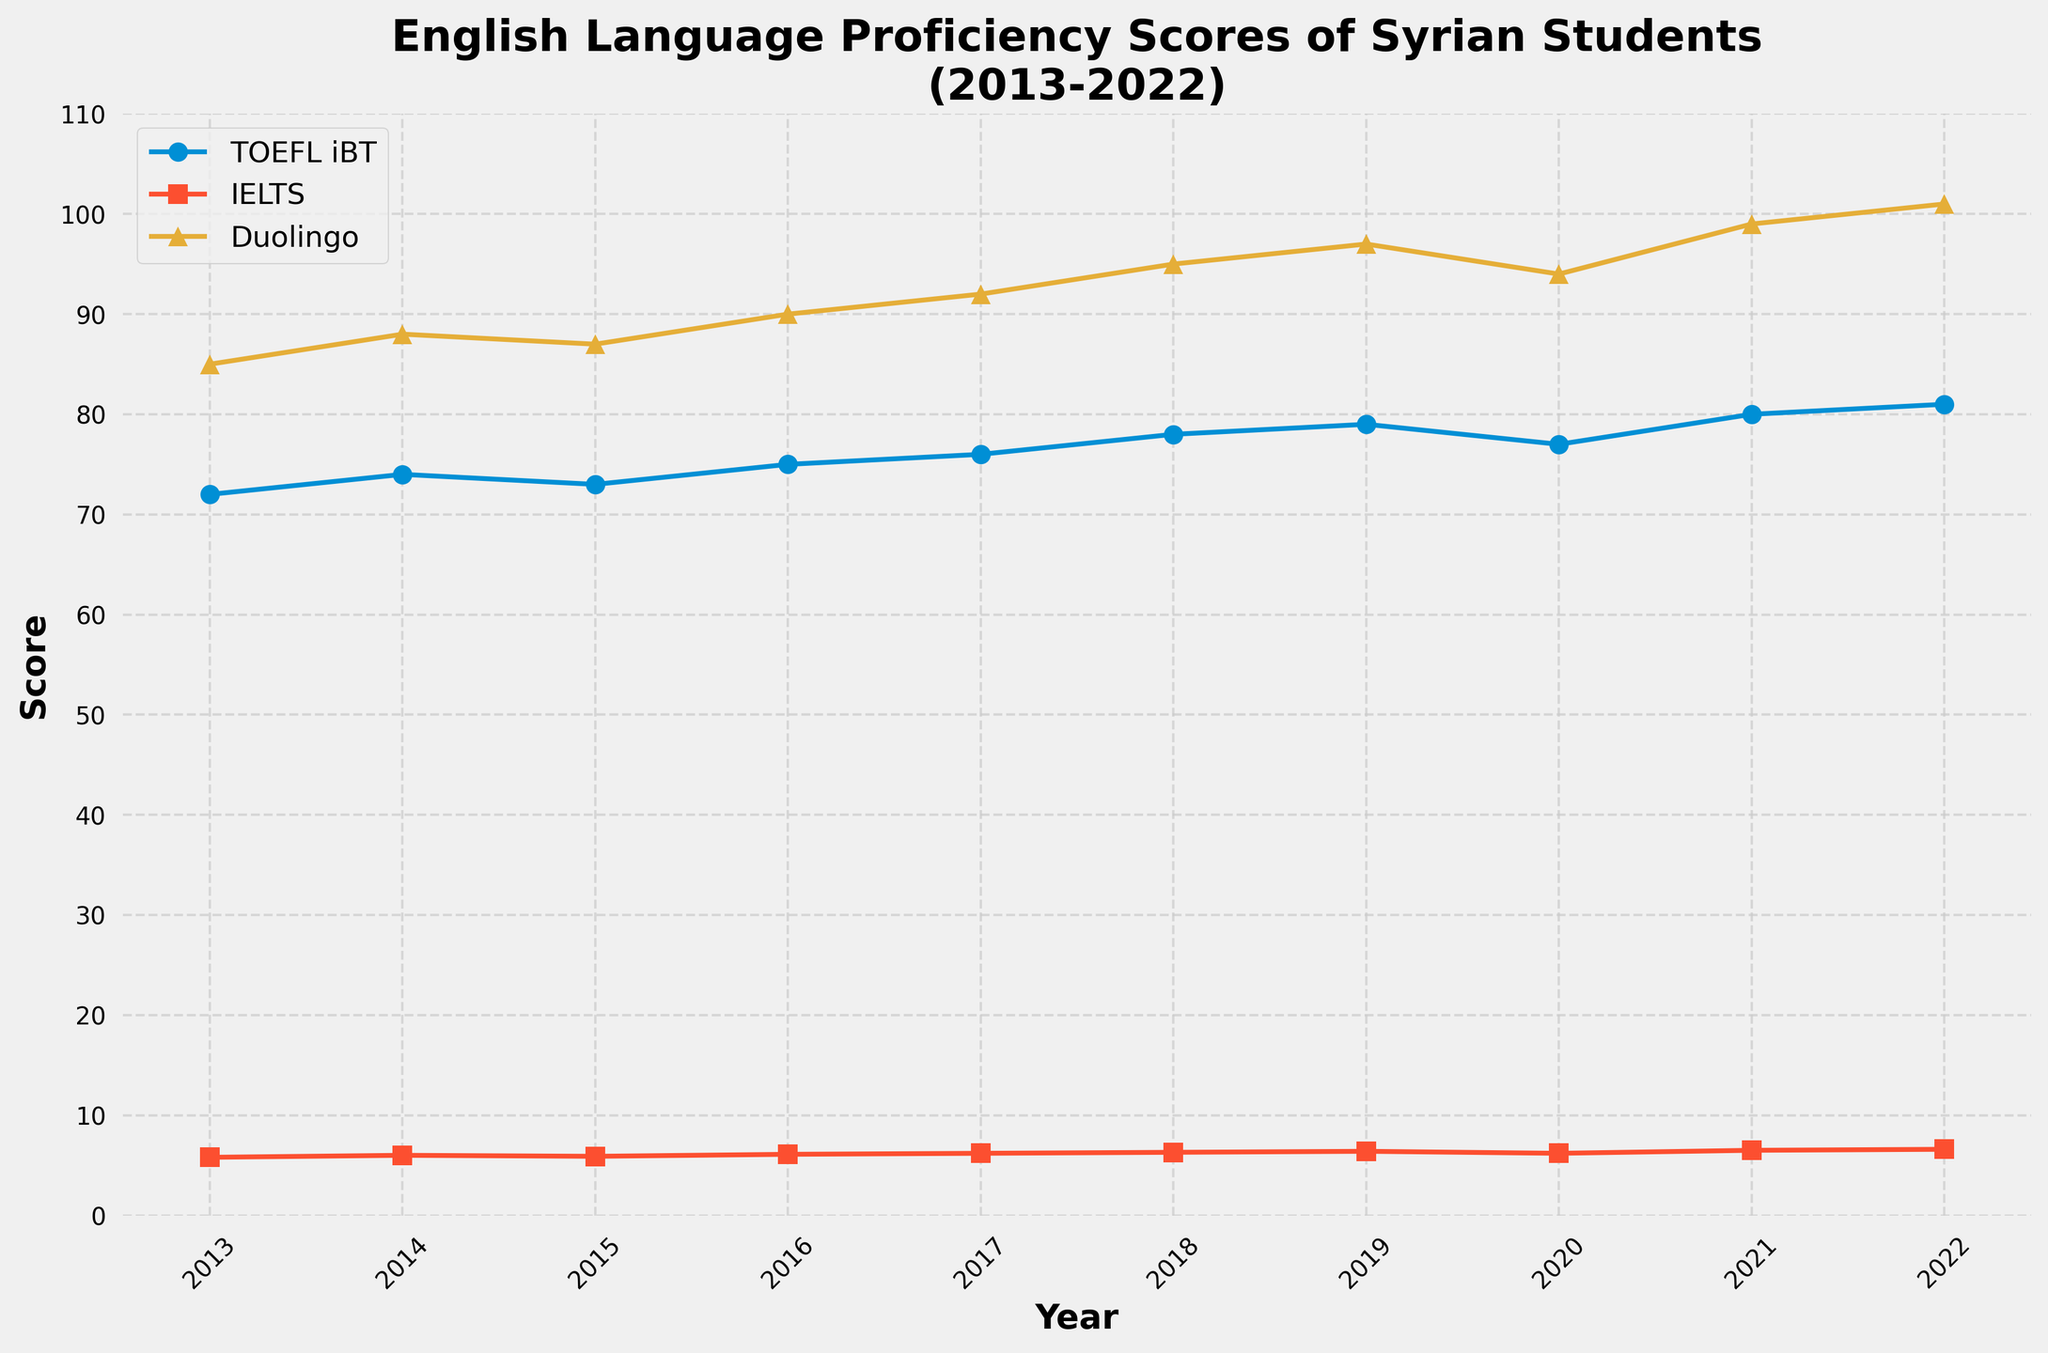what is the highest average score observed for the TOEFL iBT? Look at the line representing TOEFL iBT and find the peak value, which occurs in 2022 with a score of 81.
Answer: 81 In which year did the IELTS average score first reach 6.5? Identify the point where the IELTS line crosses the value of 6.5 on the y-axis, which is in 2021.
Answer: 2021 How much did the Duolingo English Test average score increase from 2013 to 2022? Find the Duolingo scores for 2013 and 2022, then subtract the 2013 score (85) from the 2022 score (101).
Answer: 16 Between 2017 and 2020, which year had the lowest TOEFL iBT average score? Compare the TOEFL iBT scores for 2017 (76), 2018 (78), 2019 (79), and 2020 (77); the lowest score is in 2017.
Answer: 2017 Calculate the average of IELTS scores in 2015, 2016, and 2017. Add IELTS scores for 2015 (5.9), 2016 (6.1), and 2017 (6.2), then divide by 3. (5.9 + 6.1 + 6.2)/3 = 6.067
Answer: 6.1 Which test showed the most improvement from 2018 to 2022? Calculate the differences for each test between 2018 and 2022: TOEFL (81-78=3), IELTS (6.6-6.3=0.3), Duolingo (101-95=6). Duolingo has the greatest improvement.
Answer: Duolingo English Test Did any test scores decrease between 2019 and 2020? Observe the trends for each test from 2019 to 2020: TOEFL decreases (79 to 77), IELTS decreases (6.4 to 6.2), Duolingo decreases (97 to 94).
Answer: Yes Which year saw the highest combined total score across all three tests? Sum the scores for each year and determine the highest: 2013 (72+5.8+85 = 162.8), 2014 (74+6.0+88 = 168), …, 2022 (81+6.6+101 = 188.6); 2022 is highest.
Answer: 2022 